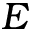Convert formula to latex. <formula><loc_0><loc_0><loc_500><loc_500>E</formula> 